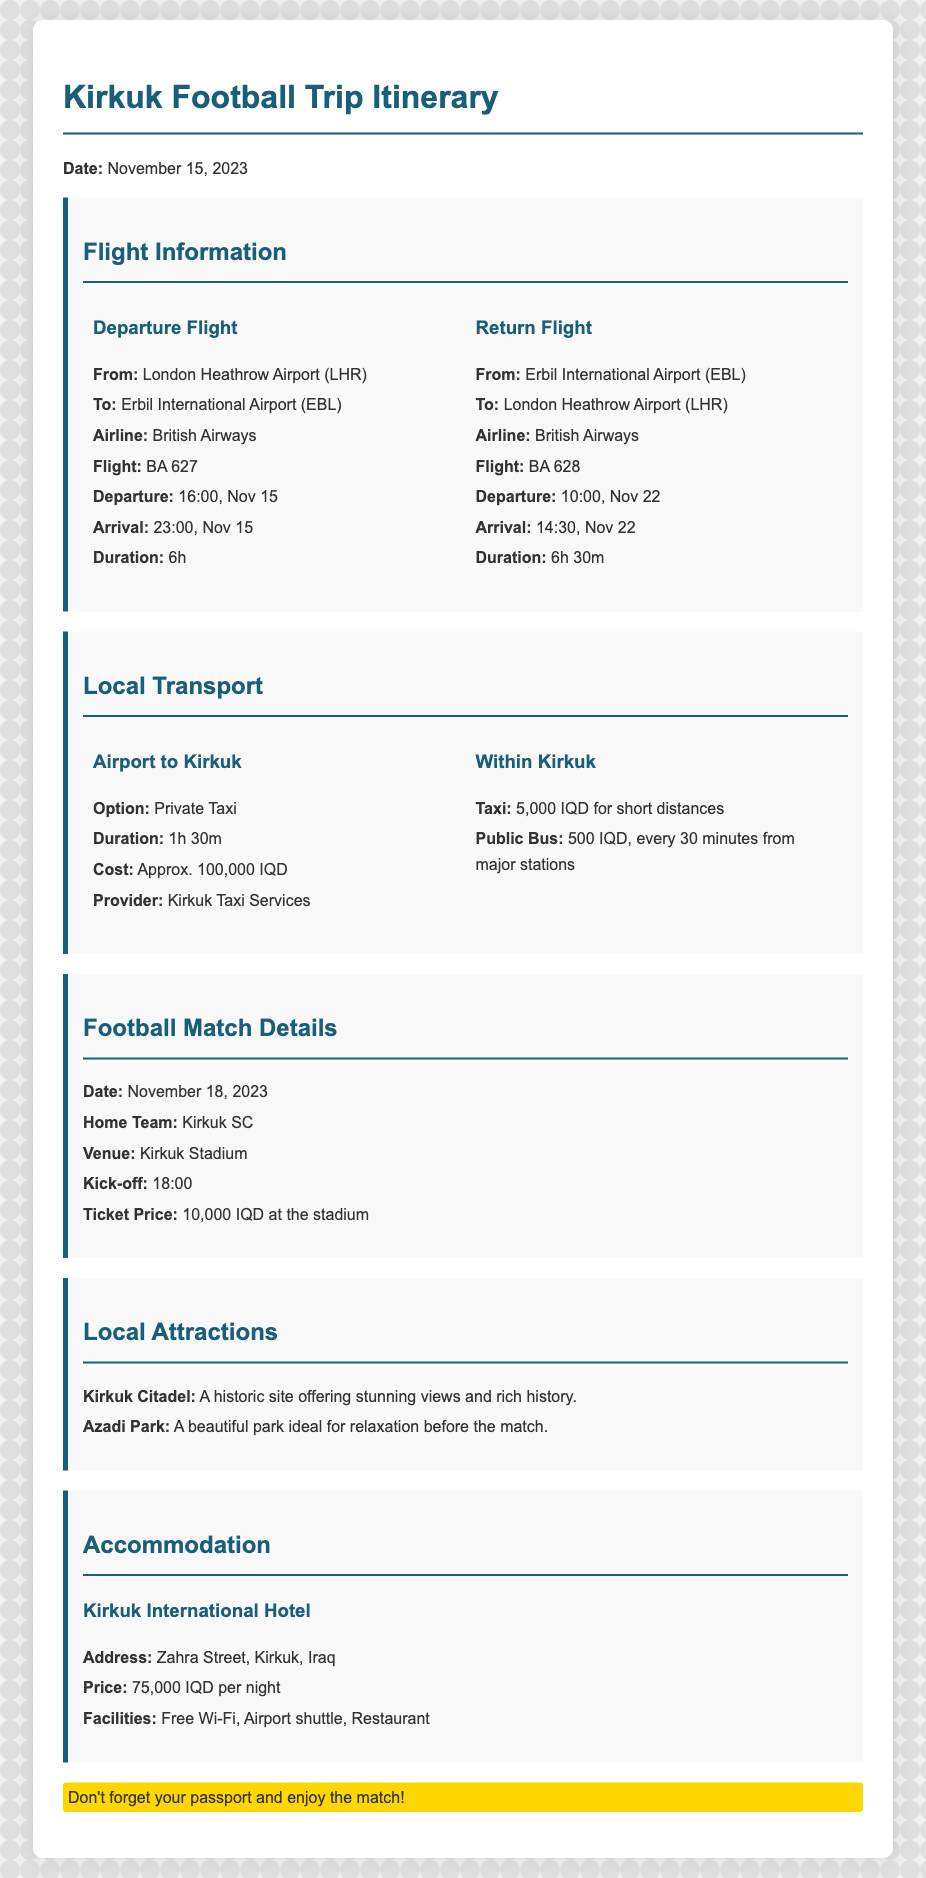What is the departure flight from London? The departure flight is from London Heathrow Airport (LHR) to Erbil International Airport (EBL) on British Airways flight BA 627.
Answer: BA 627 What is the duration of the return flight? The duration of the return flight from Erbil International Airport (EBL) to London Heathrow Airport (LHR) is 6 hours and 30 minutes.
Answer: 6h 30m How much does a private taxi from the airport to Kirkuk cost? The cost of a private taxi from the airport to Kirkuk is approximately 100,000 IQD.
Answer: 100,000 IQD What date is the football match scheduled? The football match is scheduled for November 18, 2023.
Answer: November 18, 2023 Where is the accommodation located? The accommodation, Kirkuk International Hotel, is located on Zahra Street, Kirkuk, Iraq.
Answer: Zahra Street, Kirkuk, Iraq What is the ticket price for the football match? The ticket price for the football match at the stadium is 10,000 IQD.
Answer: 10,000 IQD What is the home team for the match? The home team for the match is Kirkuk SC.
Answer: Kirkuk SC What local attraction is listed? The local attractions include Kirkuk Citadel and Azadi Park.
Answer: Kirkuk Citadel How often do public buses run within Kirkuk? Public buses run every 30 minutes from major stations within Kirkuk.
Answer: Every 30 minutes 